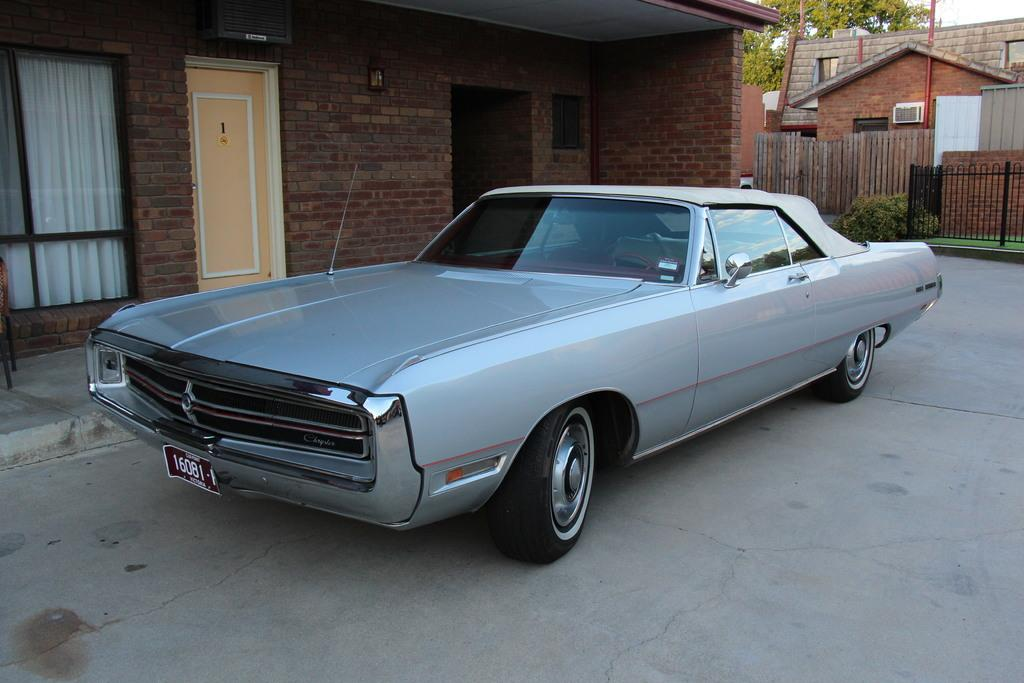What is the main subject in the foreground of the image? There is a car in the foreground of the image. Where is the car located? The car is on the road. What can be seen in the background of the image? There are buildings, plants, a railing, a door, windows, trees, and the sky visible in the background of the image. What type of toothpaste is being advertised on the car in the image? There is no toothpaste or advertisement present on the car in the image. 